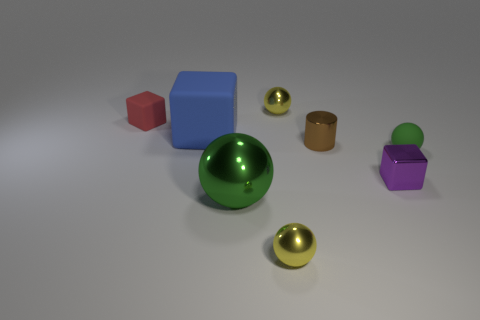Subtract all tiny green rubber balls. How many balls are left? 3 Add 1 tiny green metallic things. How many objects exist? 9 Subtract 3 balls. How many balls are left? 1 Subtract 0 yellow blocks. How many objects are left? 8 Subtract all cylinders. How many objects are left? 7 Subtract all purple blocks. Subtract all cyan cylinders. How many blocks are left? 2 Subtract all blue cylinders. How many green balls are left? 2 Subtract all large red matte cubes. Subtract all purple blocks. How many objects are left? 7 Add 2 tiny blocks. How many tiny blocks are left? 4 Add 6 big rubber cubes. How many big rubber cubes exist? 7 